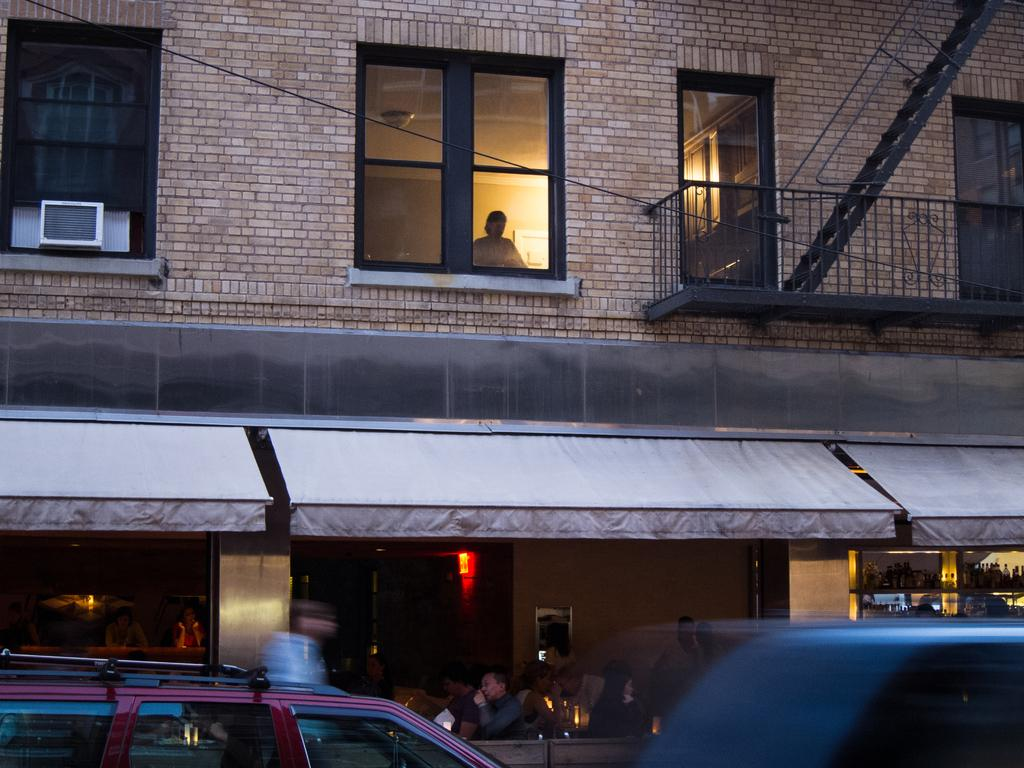What type of vehicles can be seen in the image? There are cars in the image. What is located behind the cars? There is a building behind the cars. What are people doing inside the building? There are people sitting on chairs in the building. What architectural feature can be seen on the building? There are windows on top of the building. What type of lumber is being used to construct the house in the image? There is no house present in the image, only a building with windows and people sitting on chairs. 